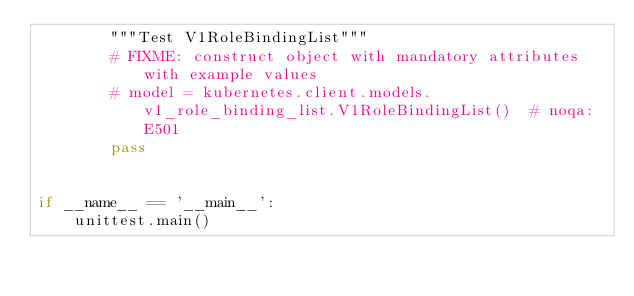Convert code to text. <code><loc_0><loc_0><loc_500><loc_500><_Python_>        """Test V1RoleBindingList"""
        # FIXME: construct object with mandatory attributes with example values
        # model = kubernetes.client.models.v1_role_binding_list.V1RoleBindingList()  # noqa: E501
        pass


if __name__ == '__main__':
    unittest.main()
</code> 